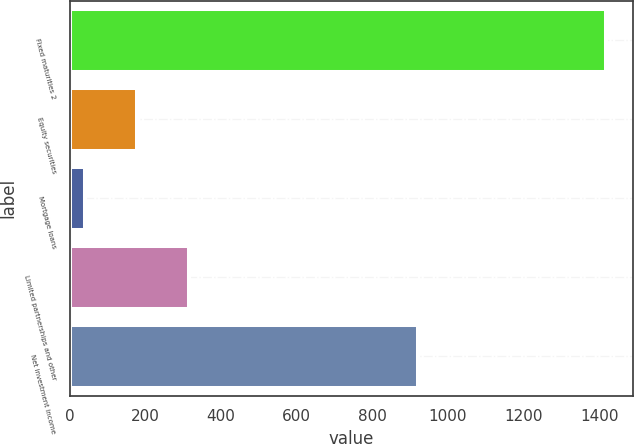Convert chart. <chart><loc_0><loc_0><loc_500><loc_500><bar_chart><fcel>Fixed maturities 2<fcel>Equity securities<fcel>Mortgage loans<fcel>Limited partnerships and other<fcel>Net investment income<nl><fcel>1418<fcel>177.8<fcel>40<fcel>315.6<fcel>921<nl></chart> 